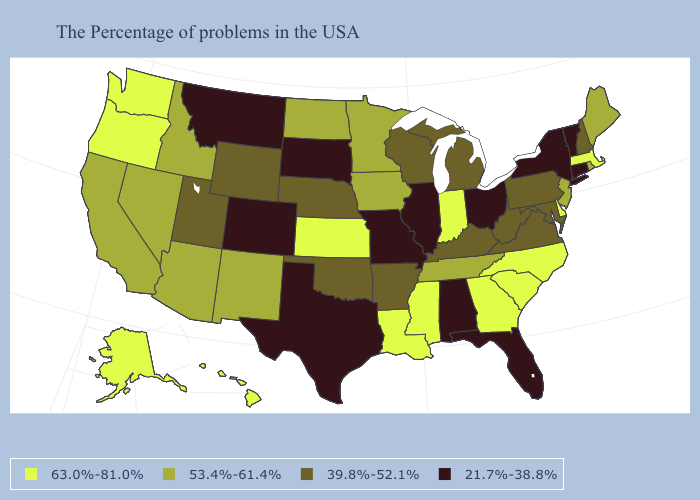How many symbols are there in the legend?
Keep it brief. 4. What is the highest value in the USA?
Be succinct. 63.0%-81.0%. Which states have the lowest value in the South?
Quick response, please. Florida, Alabama, Texas. What is the lowest value in the USA?
Short answer required. 21.7%-38.8%. Does New Jersey have a lower value than Mississippi?
Short answer required. Yes. What is the lowest value in the USA?
Be succinct. 21.7%-38.8%. What is the value of Mississippi?
Quick response, please. 63.0%-81.0%. Which states hav the highest value in the MidWest?
Answer briefly. Indiana, Kansas. What is the highest value in the South ?
Keep it brief. 63.0%-81.0%. Does New York have the lowest value in the Northeast?
Be succinct. Yes. Does Arizona have the highest value in the West?
Give a very brief answer. No. Which states have the lowest value in the MidWest?
Keep it brief. Ohio, Illinois, Missouri, South Dakota. Name the states that have a value in the range 63.0%-81.0%?
Answer briefly. Massachusetts, Delaware, North Carolina, South Carolina, Georgia, Indiana, Mississippi, Louisiana, Kansas, Washington, Oregon, Alaska, Hawaii. Which states have the lowest value in the USA?
Be succinct. Vermont, Connecticut, New York, Ohio, Florida, Alabama, Illinois, Missouri, Texas, South Dakota, Colorado, Montana. What is the lowest value in the USA?
Keep it brief. 21.7%-38.8%. 